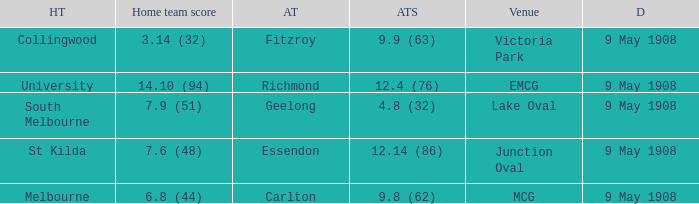Parse the table in full. {'header': ['HT', 'Home team score', 'AT', 'ATS', 'Venue', 'D'], 'rows': [['Collingwood', '3.14 (32)', 'Fitzroy', '9.9 (63)', 'Victoria Park', '9 May 1908'], ['University', '14.10 (94)', 'Richmond', '12.4 (76)', 'EMCG', '9 May 1908'], ['South Melbourne', '7.9 (51)', 'Geelong', '4.8 (32)', 'Lake Oval', '9 May 1908'], ['St Kilda', '7.6 (48)', 'Essendon', '12.14 (86)', 'Junction Oval', '9 May 1908'], ['Melbourne', '6.8 (44)', 'Carlton', '9.8 (62)', 'MCG', '9 May 1908']]} Name the away team score for lake oval 4.8 (32). 